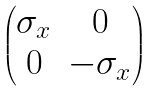Convert formula to latex. <formula><loc_0><loc_0><loc_500><loc_500>\begin{pmatrix} \sigma _ { x } & 0 \\ 0 & - \sigma _ { x } \end{pmatrix}</formula> 